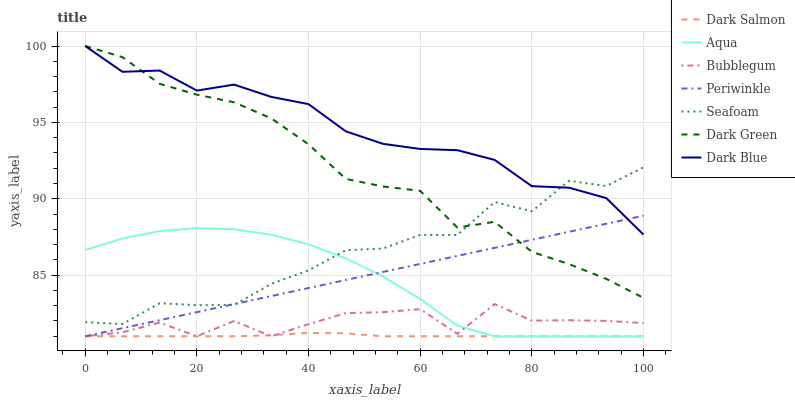Does Dark Salmon have the minimum area under the curve?
Answer yes or no. Yes. Does Dark Blue have the maximum area under the curve?
Answer yes or no. Yes. Does Bubblegum have the minimum area under the curve?
Answer yes or no. No. Does Bubblegum have the maximum area under the curve?
Answer yes or no. No. Is Periwinkle the smoothest?
Answer yes or no. Yes. Is Seafoam the roughest?
Answer yes or no. Yes. Is Dark Salmon the smoothest?
Answer yes or no. No. Is Dark Salmon the roughest?
Answer yes or no. No. Does Aqua have the lowest value?
Answer yes or no. Yes. Does Seafoam have the lowest value?
Answer yes or no. No. Does Dark Green have the highest value?
Answer yes or no. Yes. Does Bubblegum have the highest value?
Answer yes or no. No. Is Bubblegum less than Seafoam?
Answer yes or no. Yes. Is Dark Green greater than Dark Salmon?
Answer yes or no. Yes. Does Seafoam intersect Dark Green?
Answer yes or no. Yes. Is Seafoam less than Dark Green?
Answer yes or no. No. Is Seafoam greater than Dark Green?
Answer yes or no. No. Does Bubblegum intersect Seafoam?
Answer yes or no. No. 